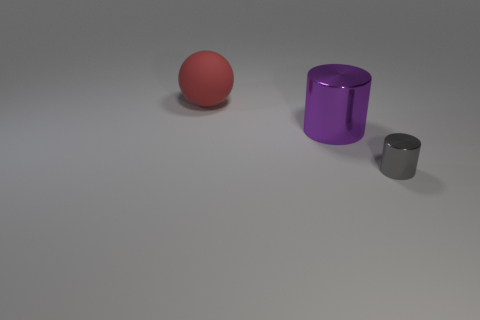Add 2 brown objects. How many objects exist? 5 Subtract all cylinders. How many objects are left? 1 Subtract 0 cyan cylinders. How many objects are left? 3 Subtract all spheres. Subtract all rubber spheres. How many objects are left? 1 Add 2 big purple objects. How many big purple objects are left? 3 Add 2 small blue things. How many small blue things exist? 2 